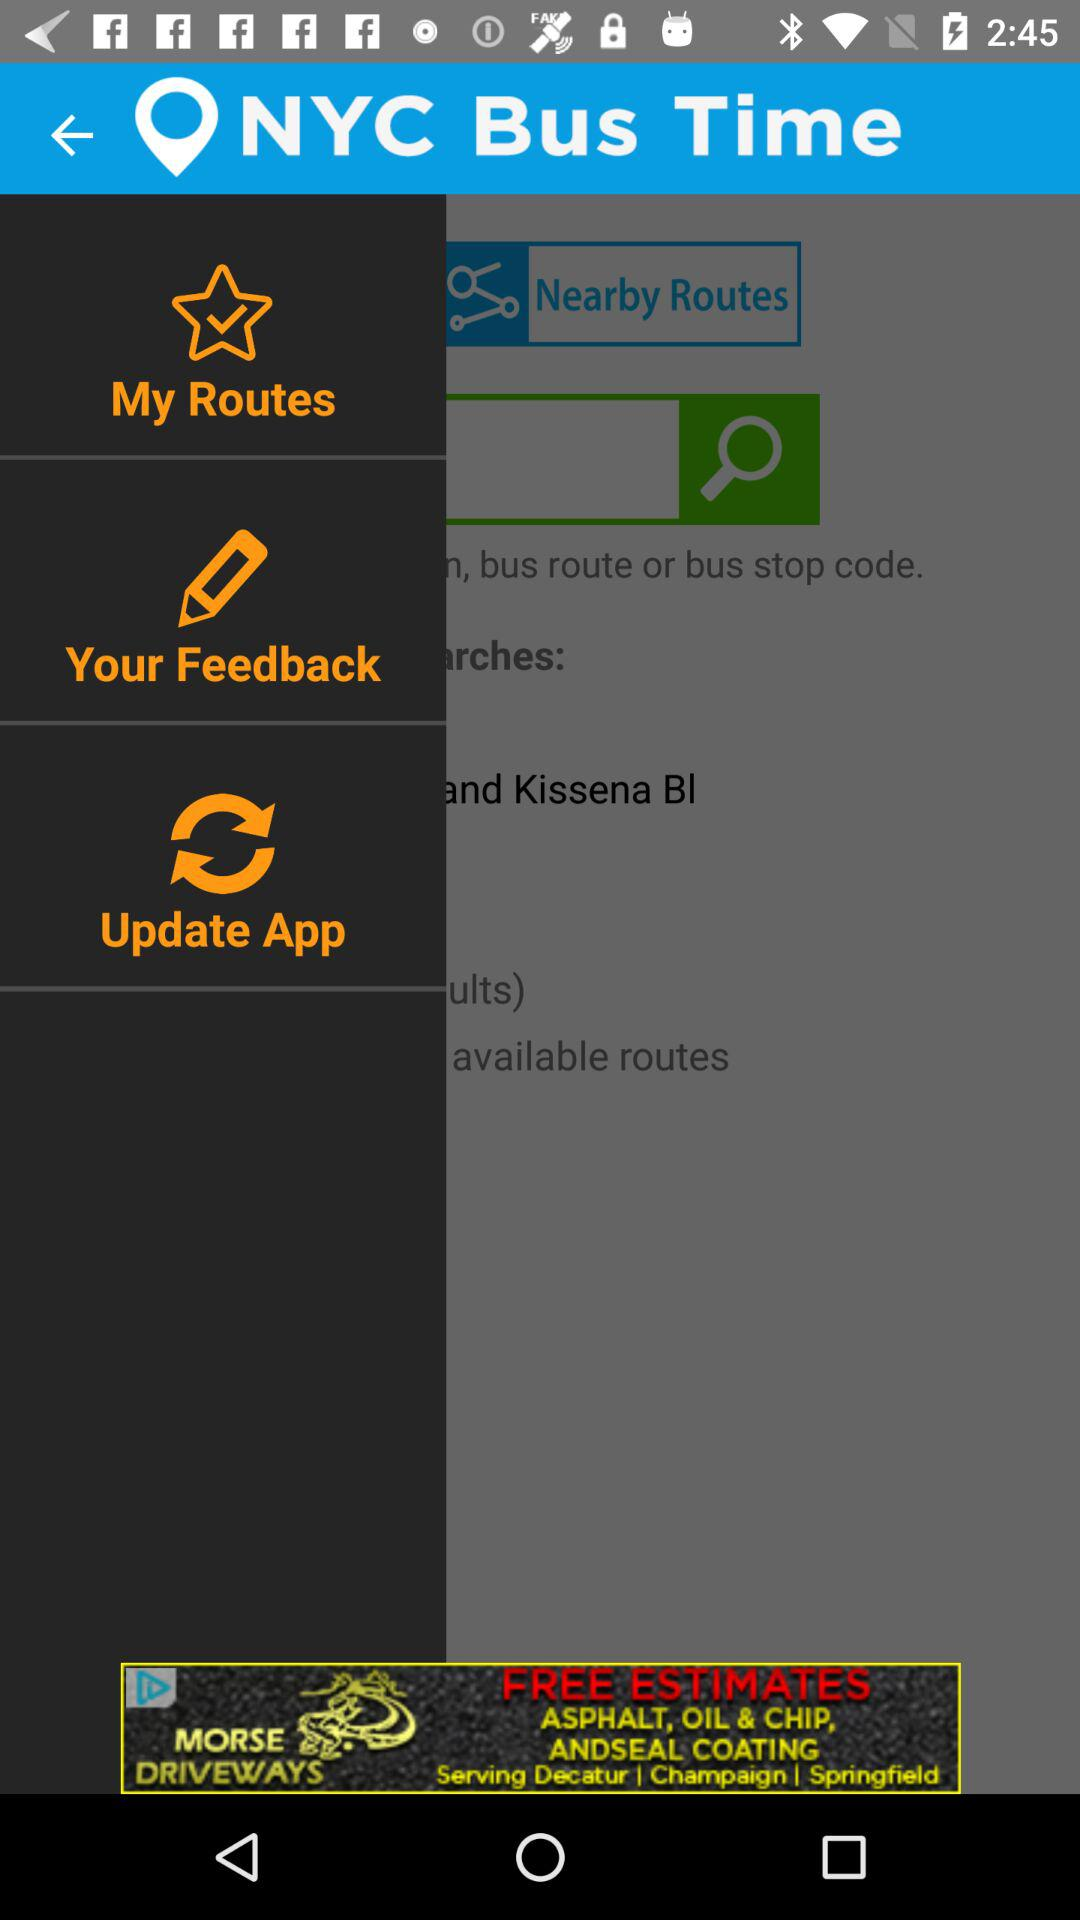What is the name of the application? The name of the application is "NYC Bus Time". 